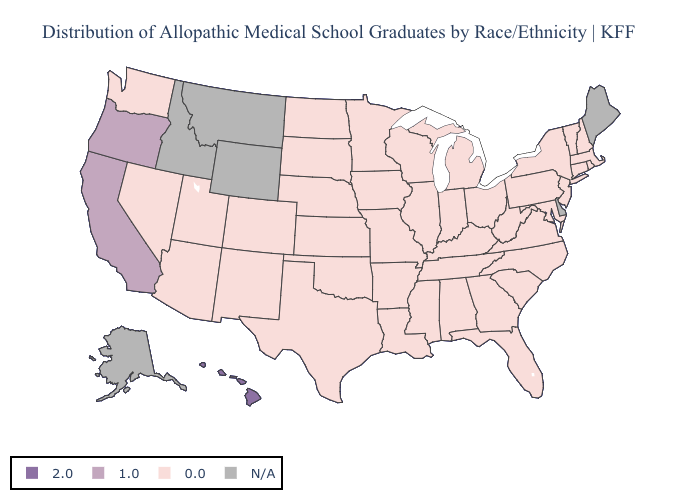What is the value of Illinois?
Short answer required. 0.0. What is the lowest value in the South?
Write a very short answer. 0.0. How many symbols are there in the legend?
Short answer required. 4. Name the states that have a value in the range 1.0?
Give a very brief answer. California, Oregon. Name the states that have a value in the range 1.0?
Give a very brief answer. California, Oregon. What is the value of Oregon?
Short answer required. 1.0. Which states have the lowest value in the South?
Write a very short answer. Alabama, Arkansas, Florida, Georgia, Kentucky, Louisiana, Maryland, Mississippi, North Carolina, Oklahoma, South Carolina, Tennessee, Texas, Virginia, West Virginia. Name the states that have a value in the range 0.0?
Short answer required. Alabama, Arizona, Arkansas, Colorado, Connecticut, Florida, Georgia, Illinois, Indiana, Iowa, Kansas, Kentucky, Louisiana, Maryland, Massachusetts, Michigan, Minnesota, Mississippi, Missouri, Nebraska, Nevada, New Hampshire, New Jersey, New Mexico, New York, North Carolina, North Dakota, Ohio, Oklahoma, Pennsylvania, Rhode Island, South Carolina, South Dakota, Tennessee, Texas, Utah, Vermont, Virginia, Washington, West Virginia, Wisconsin. Name the states that have a value in the range 0.0?
Concise answer only. Alabama, Arizona, Arkansas, Colorado, Connecticut, Florida, Georgia, Illinois, Indiana, Iowa, Kansas, Kentucky, Louisiana, Maryland, Massachusetts, Michigan, Minnesota, Mississippi, Missouri, Nebraska, Nevada, New Hampshire, New Jersey, New Mexico, New York, North Carolina, North Dakota, Ohio, Oklahoma, Pennsylvania, Rhode Island, South Carolina, South Dakota, Tennessee, Texas, Utah, Vermont, Virginia, Washington, West Virginia, Wisconsin. What is the value of North Dakota?
Write a very short answer. 0.0. What is the value of New Hampshire?
Answer briefly. 0.0. Which states have the highest value in the USA?
Keep it brief. Hawaii. 